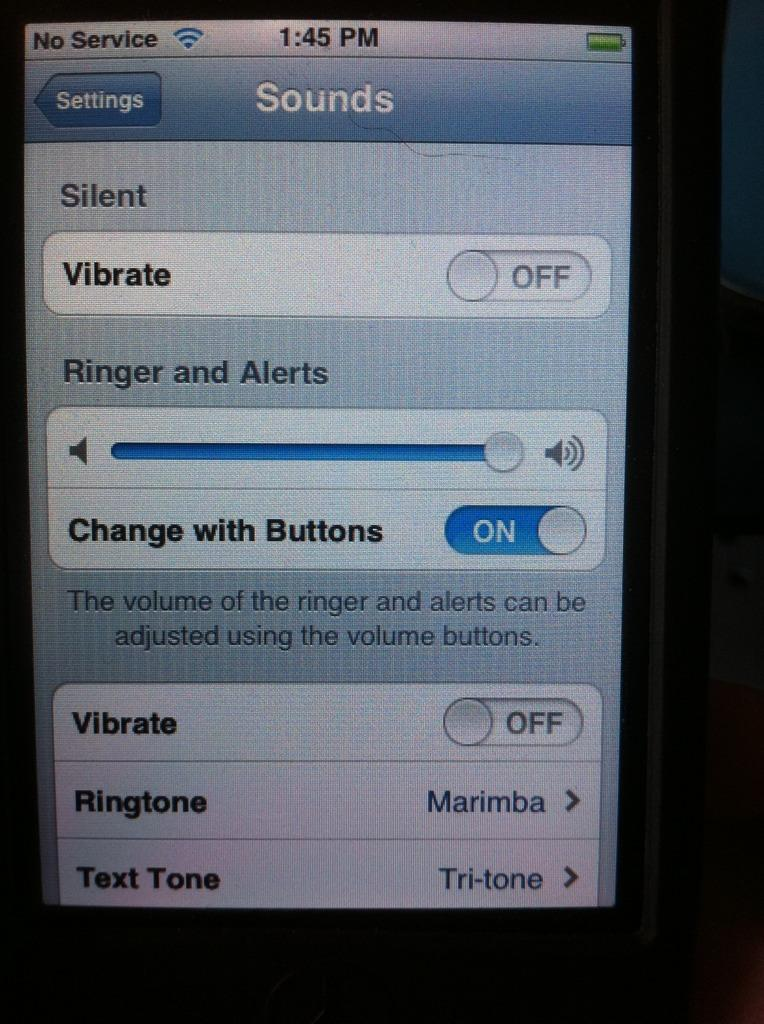<image>
Provide a brief description of the given image. a phone that has the word vibrate on it 